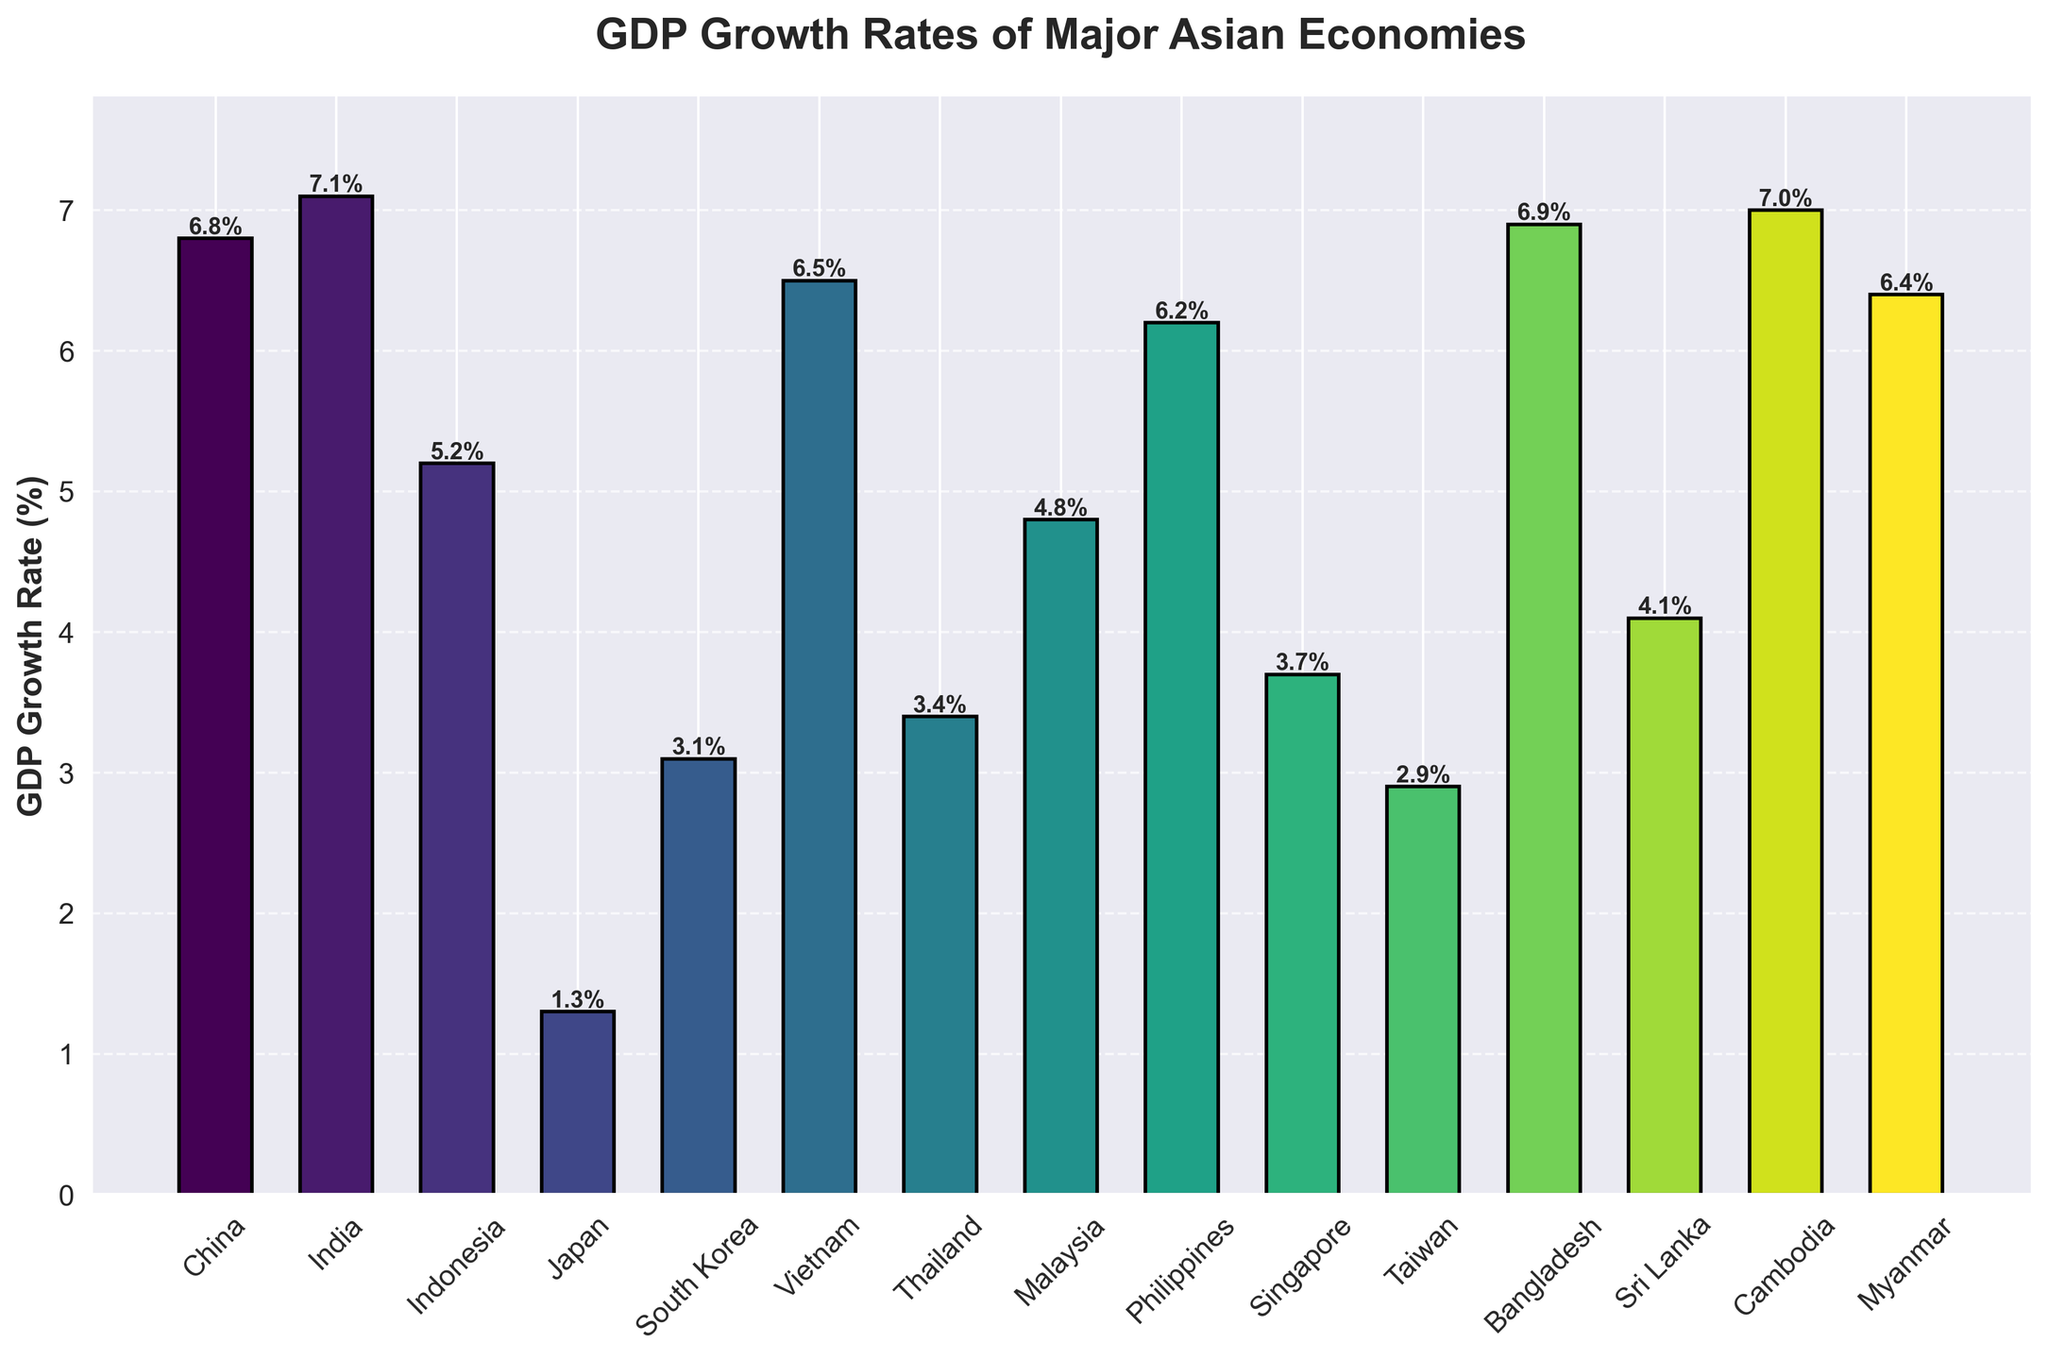What's the highest GDP growth rate among the major Asian economies? The tallest bar in the chart represents the highest GDP growth rate. According to the labels, it belongs to India with a rate of 7.1%.
Answer: 7.1% Which countries have a GDP growth rate higher than 6%? The bars that extend beyond the 6% mark on the y-axis indicate the countries with growth rates higher than 6%. The countries are China, India, Bangladesh, Vietnam, Cambodia, Myanmar, and the Philippines.
Answer: China, India, Bangladesh, Vietnam, Cambodia, Myanmar, Philippines Which country has the lowest GDP growth rate? The shortest bar on the chart indicates the lowest GDP growth rate. According to the labels, it belongs to Japan with a rate of 1.3%.
Answer: Japan What is the average GDP growth rate of Japan, South Korea, and Taiwan? The GDP growth rates for Japan, South Korea, and Taiwan are 1.3%, 3.1%, and 2.9%, respectively. Their average is calculated as (1.3 + 3.1 + 2.9) / 3 = 2.43%.
Answer: 2.43% What is the difference in GDP growth rate between the country with the highest rate and the country with the lowest rate? The highest GDP growth rate is 7.1% (India), and the lowest is 1.3% (Japan). The difference is calculated as 7.1% - 1.3% = 5.8%.
Answer: 5.8% Are there more countries with a GDP growth rate below 4% or above 4%? Count the number of bars that are below and above the 4% mark on the y-axis. There are 5 countries below 4% (Japan, South Korea, Taiwan, Sri Lanka, and Thailand) and 10 countries above 4%.
Answer: Above 4% What's the combined GDP growth rate of Indonesia, Malaysia, and the Philippines? The GDP growth rates for Indonesia, Malaysia, and the Philippines are 5.2%, 4.8%, and 6.2%, respectively. Their combined rate is calculated as 5.2 + 4.8 + 6.2 = 16.2%.
Answer: 16.2% Which two countries have nearly equal GDP growth rates? By looking at the heights of the bars and their labels, Sri Lanka (4.1%) and Malaysia (4.8%) have close GDP growth rates.
Answer: Sri Lanka and Malaysia What is the sum of the GDP growth rates for the three countries with the highest growth rates? The three countries with the highest GDP growth rates are India (7.1%), Cambodia (7.0%), and Bangladesh (6.9%). The sum is calculated as 7.1 + 7.0 + 6.9 = 21.0%.
Answer: 21.0% How does Vietnam's GDP growth rate compare visually to Thailand's? By looking at the heights of the bars, Vietnam's bar is noticeably taller than Thailand's. Vietnam (6.5%) has a higher GDP growth rate than Thailand (3.4%).
Answer: Higher 